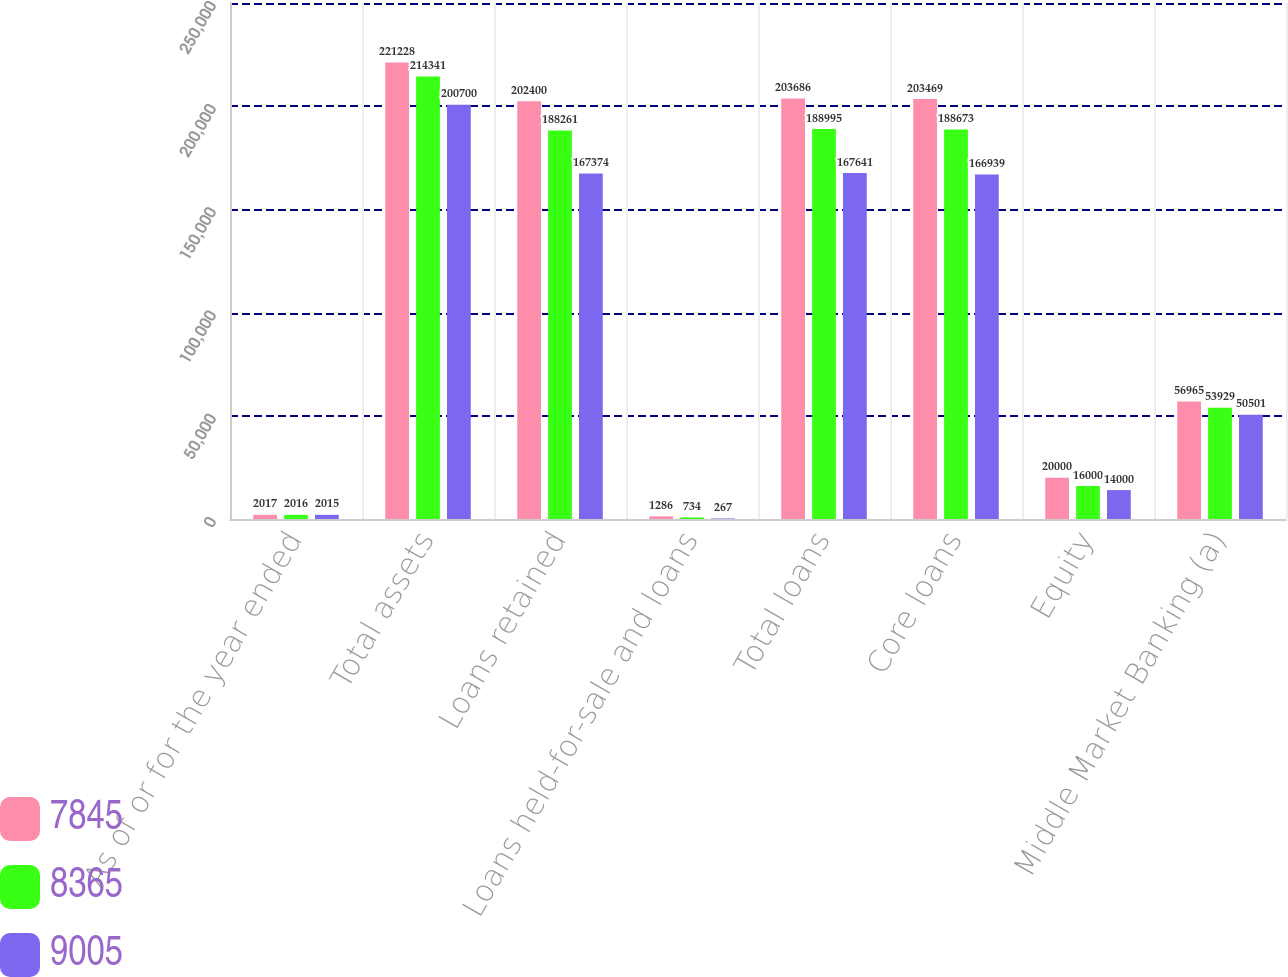<chart> <loc_0><loc_0><loc_500><loc_500><stacked_bar_chart><ecel><fcel>As of or for the year ended<fcel>Total assets<fcel>Loans retained<fcel>Loans held-for-sale and loans<fcel>Total loans<fcel>Core loans<fcel>Equity<fcel>Middle Market Banking (a)<nl><fcel>7845<fcel>2017<fcel>221228<fcel>202400<fcel>1286<fcel>203686<fcel>203469<fcel>20000<fcel>56965<nl><fcel>8365<fcel>2016<fcel>214341<fcel>188261<fcel>734<fcel>188995<fcel>188673<fcel>16000<fcel>53929<nl><fcel>9005<fcel>2015<fcel>200700<fcel>167374<fcel>267<fcel>167641<fcel>166939<fcel>14000<fcel>50501<nl></chart> 